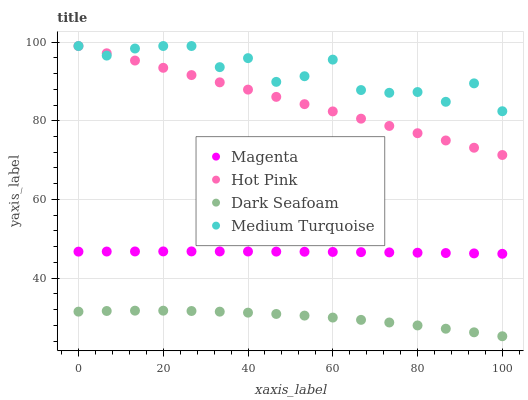Does Dark Seafoam have the minimum area under the curve?
Answer yes or no. Yes. Does Medium Turquoise have the maximum area under the curve?
Answer yes or no. Yes. Does Hot Pink have the minimum area under the curve?
Answer yes or no. No. Does Hot Pink have the maximum area under the curve?
Answer yes or no. No. Is Hot Pink the smoothest?
Answer yes or no. Yes. Is Medium Turquoise the roughest?
Answer yes or no. Yes. Is Dark Seafoam the smoothest?
Answer yes or no. No. Is Dark Seafoam the roughest?
Answer yes or no. No. Does Dark Seafoam have the lowest value?
Answer yes or no. Yes. Does Hot Pink have the lowest value?
Answer yes or no. No. Does Medium Turquoise have the highest value?
Answer yes or no. Yes. Does Dark Seafoam have the highest value?
Answer yes or no. No. Is Magenta less than Medium Turquoise?
Answer yes or no. Yes. Is Medium Turquoise greater than Magenta?
Answer yes or no. Yes. Does Medium Turquoise intersect Hot Pink?
Answer yes or no. Yes. Is Medium Turquoise less than Hot Pink?
Answer yes or no. No. Is Medium Turquoise greater than Hot Pink?
Answer yes or no. No. Does Magenta intersect Medium Turquoise?
Answer yes or no. No. 